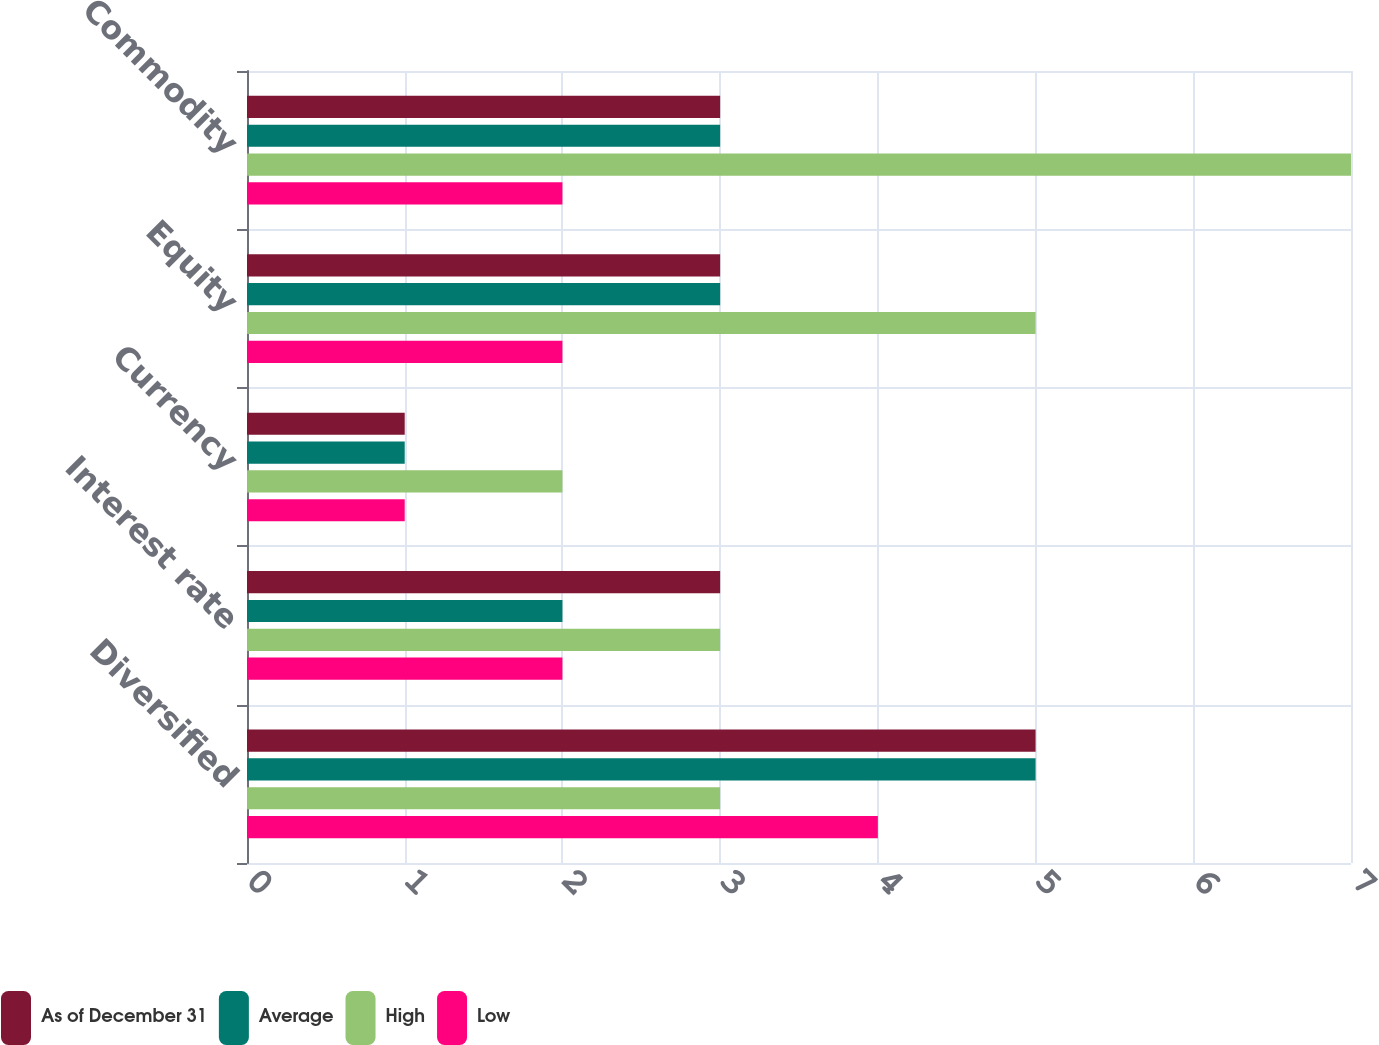Convert chart to OTSL. <chart><loc_0><loc_0><loc_500><loc_500><stacked_bar_chart><ecel><fcel>Diversified<fcel>Interest rate<fcel>Currency<fcel>Equity<fcel>Commodity<nl><fcel>As of December 31<fcel>5<fcel>3<fcel>1<fcel>3<fcel>3<nl><fcel>Average<fcel>5<fcel>2<fcel>1<fcel>3<fcel>3<nl><fcel>High<fcel>3<fcel>3<fcel>2<fcel>5<fcel>7<nl><fcel>Low<fcel>4<fcel>2<fcel>1<fcel>2<fcel>2<nl></chart> 